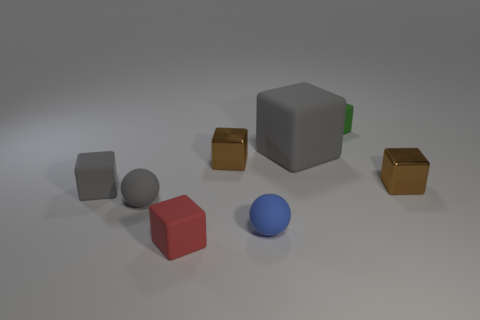There is a brown object right of the blue rubber sphere; does it have the same size as the small gray cube?
Provide a short and direct response. Yes. The green object that is the same shape as the tiny red matte object is what size?
Make the answer very short. Small. Is there anything else that is the same size as the red object?
Offer a very short reply. Yes. Is the small red matte thing the same shape as the tiny green rubber thing?
Your response must be concise. Yes. Are there fewer things in front of the green rubber cube than small rubber things to the right of the gray rubber ball?
Your answer should be very brief. No. There is a red thing; what number of gray matte things are on the right side of it?
Your response must be concise. 1. There is a brown metallic thing that is on the left side of the tiny green thing; is it the same shape as the thing in front of the blue thing?
Offer a very short reply. Yes. How many other things are the same color as the big rubber thing?
Your response must be concise. 2. What is the material of the tiny brown block on the right side of the small green rubber object that is behind the matte ball that is on the right side of the small red matte thing?
Make the answer very short. Metal. What is the small brown block that is to the right of the small rubber block that is to the right of the large block made of?
Keep it short and to the point. Metal. 